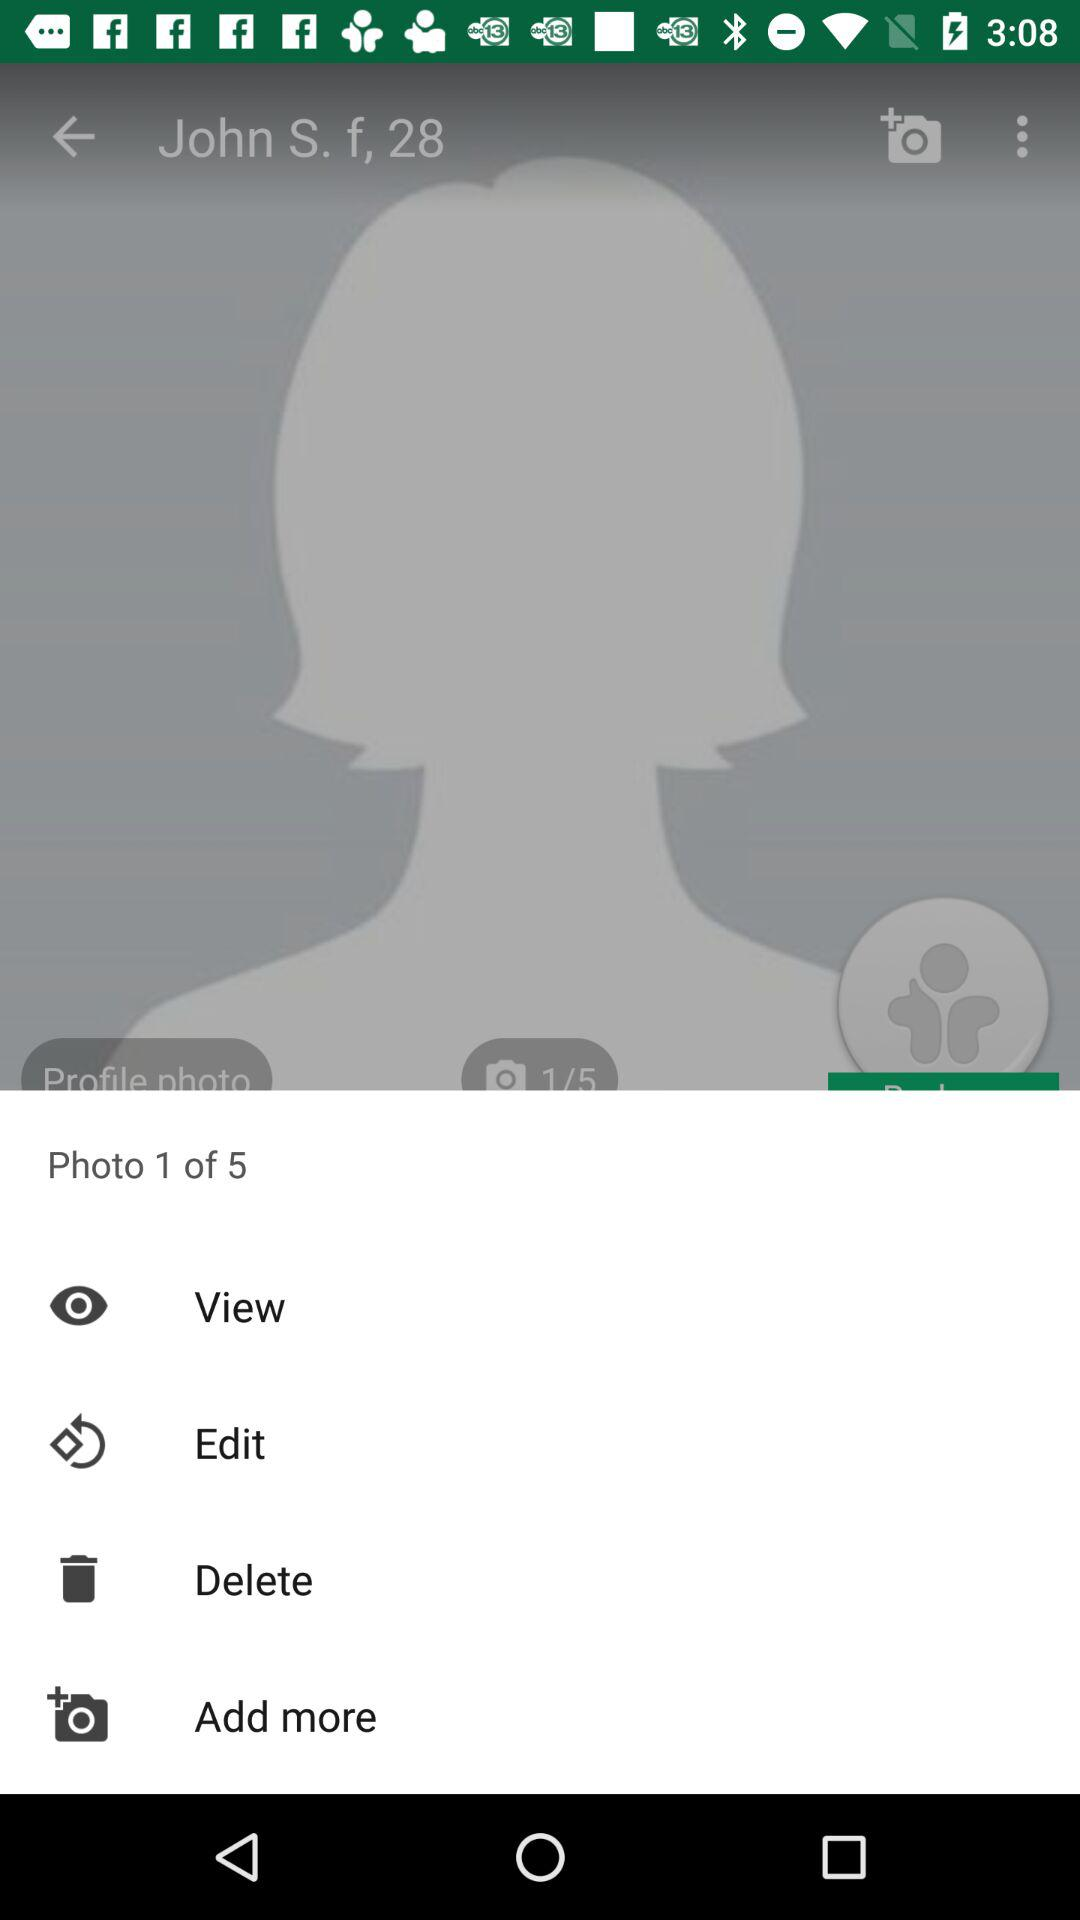How many items have been deleted?
When the provided information is insufficient, respond with <no answer>. <no answer> 